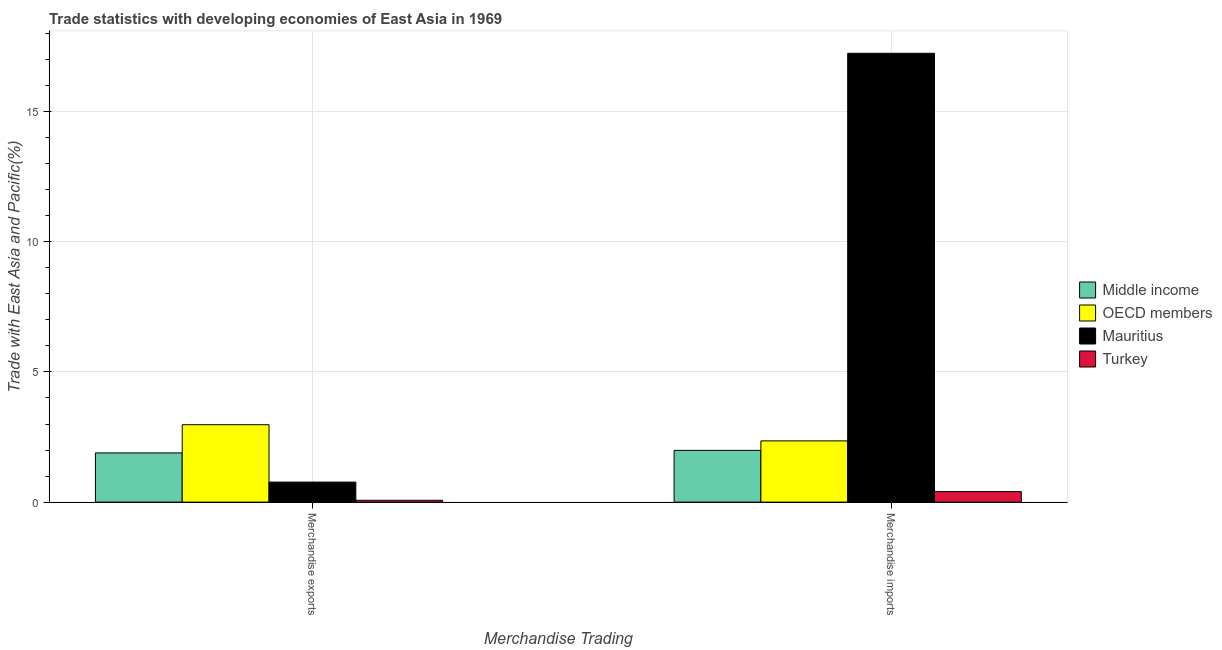Are the number of bars per tick equal to the number of legend labels?
Your answer should be compact. Yes. How many bars are there on the 1st tick from the right?
Make the answer very short. 4. What is the label of the 2nd group of bars from the left?
Provide a succinct answer. Merchandise imports. What is the merchandise exports in OECD members?
Your answer should be compact. 2.97. Across all countries, what is the maximum merchandise exports?
Keep it short and to the point. 2.97. Across all countries, what is the minimum merchandise imports?
Your response must be concise. 0.4. In which country was the merchandise imports maximum?
Provide a short and direct response. Mauritius. In which country was the merchandise exports minimum?
Offer a very short reply. Turkey. What is the total merchandise exports in the graph?
Your answer should be compact. 5.7. What is the difference between the merchandise imports in Middle income and that in OECD members?
Ensure brevity in your answer.  -0.37. What is the difference between the merchandise exports in Mauritius and the merchandise imports in Middle income?
Make the answer very short. -1.22. What is the average merchandise exports per country?
Provide a succinct answer. 1.43. What is the difference between the merchandise exports and merchandise imports in Middle income?
Make the answer very short. -0.1. In how many countries, is the merchandise imports greater than 3 %?
Your answer should be compact. 1. What is the ratio of the merchandise exports in Mauritius to that in OECD members?
Your response must be concise. 0.26. What does the 2nd bar from the left in Merchandise exports represents?
Your answer should be very brief. OECD members. How many bars are there?
Make the answer very short. 8. How many countries are there in the graph?
Give a very brief answer. 4. Does the graph contain any zero values?
Provide a succinct answer. No. Where does the legend appear in the graph?
Your answer should be very brief. Center right. How many legend labels are there?
Provide a short and direct response. 4. How are the legend labels stacked?
Ensure brevity in your answer.  Vertical. What is the title of the graph?
Your answer should be compact. Trade statistics with developing economies of East Asia in 1969. What is the label or title of the X-axis?
Provide a short and direct response. Merchandise Trading. What is the label or title of the Y-axis?
Your answer should be very brief. Trade with East Asia and Pacific(%). What is the Trade with East Asia and Pacific(%) in Middle income in Merchandise exports?
Offer a terse response. 1.89. What is the Trade with East Asia and Pacific(%) in OECD members in Merchandise exports?
Provide a short and direct response. 2.97. What is the Trade with East Asia and Pacific(%) in Mauritius in Merchandise exports?
Provide a succinct answer. 0.77. What is the Trade with East Asia and Pacific(%) in Turkey in Merchandise exports?
Offer a terse response. 0.07. What is the Trade with East Asia and Pacific(%) of Middle income in Merchandise imports?
Your response must be concise. 1.99. What is the Trade with East Asia and Pacific(%) in OECD members in Merchandise imports?
Provide a short and direct response. 2.35. What is the Trade with East Asia and Pacific(%) in Mauritius in Merchandise imports?
Provide a short and direct response. 17.24. What is the Trade with East Asia and Pacific(%) of Turkey in Merchandise imports?
Ensure brevity in your answer.  0.4. Across all Merchandise Trading, what is the maximum Trade with East Asia and Pacific(%) in Middle income?
Ensure brevity in your answer.  1.99. Across all Merchandise Trading, what is the maximum Trade with East Asia and Pacific(%) of OECD members?
Your answer should be compact. 2.97. Across all Merchandise Trading, what is the maximum Trade with East Asia and Pacific(%) in Mauritius?
Ensure brevity in your answer.  17.24. Across all Merchandise Trading, what is the maximum Trade with East Asia and Pacific(%) in Turkey?
Provide a succinct answer. 0.4. Across all Merchandise Trading, what is the minimum Trade with East Asia and Pacific(%) of Middle income?
Offer a terse response. 1.89. Across all Merchandise Trading, what is the minimum Trade with East Asia and Pacific(%) in OECD members?
Offer a terse response. 2.35. Across all Merchandise Trading, what is the minimum Trade with East Asia and Pacific(%) in Mauritius?
Your answer should be very brief. 0.77. Across all Merchandise Trading, what is the minimum Trade with East Asia and Pacific(%) in Turkey?
Make the answer very short. 0.07. What is the total Trade with East Asia and Pacific(%) of Middle income in the graph?
Offer a very short reply. 3.88. What is the total Trade with East Asia and Pacific(%) in OECD members in the graph?
Offer a terse response. 5.33. What is the total Trade with East Asia and Pacific(%) in Mauritius in the graph?
Give a very brief answer. 18.01. What is the total Trade with East Asia and Pacific(%) of Turkey in the graph?
Offer a terse response. 0.48. What is the difference between the Trade with East Asia and Pacific(%) in Middle income in Merchandise exports and that in Merchandise imports?
Your response must be concise. -0.1. What is the difference between the Trade with East Asia and Pacific(%) in OECD members in Merchandise exports and that in Merchandise imports?
Give a very brief answer. 0.62. What is the difference between the Trade with East Asia and Pacific(%) of Mauritius in Merchandise exports and that in Merchandise imports?
Provide a succinct answer. -16.47. What is the difference between the Trade with East Asia and Pacific(%) in Turkey in Merchandise exports and that in Merchandise imports?
Provide a short and direct response. -0.33. What is the difference between the Trade with East Asia and Pacific(%) in Middle income in Merchandise exports and the Trade with East Asia and Pacific(%) in OECD members in Merchandise imports?
Provide a short and direct response. -0.46. What is the difference between the Trade with East Asia and Pacific(%) in Middle income in Merchandise exports and the Trade with East Asia and Pacific(%) in Mauritius in Merchandise imports?
Make the answer very short. -15.35. What is the difference between the Trade with East Asia and Pacific(%) in Middle income in Merchandise exports and the Trade with East Asia and Pacific(%) in Turkey in Merchandise imports?
Provide a succinct answer. 1.49. What is the difference between the Trade with East Asia and Pacific(%) in OECD members in Merchandise exports and the Trade with East Asia and Pacific(%) in Mauritius in Merchandise imports?
Your answer should be very brief. -14.27. What is the difference between the Trade with East Asia and Pacific(%) in OECD members in Merchandise exports and the Trade with East Asia and Pacific(%) in Turkey in Merchandise imports?
Ensure brevity in your answer.  2.57. What is the difference between the Trade with East Asia and Pacific(%) in Mauritius in Merchandise exports and the Trade with East Asia and Pacific(%) in Turkey in Merchandise imports?
Keep it short and to the point. 0.36. What is the average Trade with East Asia and Pacific(%) of Middle income per Merchandise Trading?
Offer a terse response. 1.94. What is the average Trade with East Asia and Pacific(%) of OECD members per Merchandise Trading?
Your answer should be very brief. 2.66. What is the average Trade with East Asia and Pacific(%) of Mauritius per Merchandise Trading?
Keep it short and to the point. 9. What is the average Trade with East Asia and Pacific(%) in Turkey per Merchandise Trading?
Provide a succinct answer. 0.24. What is the difference between the Trade with East Asia and Pacific(%) of Middle income and Trade with East Asia and Pacific(%) of OECD members in Merchandise exports?
Ensure brevity in your answer.  -1.08. What is the difference between the Trade with East Asia and Pacific(%) in Middle income and Trade with East Asia and Pacific(%) in Mauritius in Merchandise exports?
Your answer should be very brief. 1.12. What is the difference between the Trade with East Asia and Pacific(%) of Middle income and Trade with East Asia and Pacific(%) of Turkey in Merchandise exports?
Make the answer very short. 1.82. What is the difference between the Trade with East Asia and Pacific(%) in OECD members and Trade with East Asia and Pacific(%) in Mauritius in Merchandise exports?
Ensure brevity in your answer.  2.2. What is the difference between the Trade with East Asia and Pacific(%) in OECD members and Trade with East Asia and Pacific(%) in Turkey in Merchandise exports?
Provide a short and direct response. 2.9. What is the difference between the Trade with East Asia and Pacific(%) in Mauritius and Trade with East Asia and Pacific(%) in Turkey in Merchandise exports?
Give a very brief answer. 0.7. What is the difference between the Trade with East Asia and Pacific(%) of Middle income and Trade with East Asia and Pacific(%) of OECD members in Merchandise imports?
Make the answer very short. -0.36. What is the difference between the Trade with East Asia and Pacific(%) in Middle income and Trade with East Asia and Pacific(%) in Mauritius in Merchandise imports?
Keep it short and to the point. -15.25. What is the difference between the Trade with East Asia and Pacific(%) of Middle income and Trade with East Asia and Pacific(%) of Turkey in Merchandise imports?
Offer a very short reply. 1.58. What is the difference between the Trade with East Asia and Pacific(%) in OECD members and Trade with East Asia and Pacific(%) in Mauritius in Merchandise imports?
Your answer should be very brief. -14.89. What is the difference between the Trade with East Asia and Pacific(%) in OECD members and Trade with East Asia and Pacific(%) in Turkey in Merchandise imports?
Keep it short and to the point. 1.95. What is the difference between the Trade with East Asia and Pacific(%) of Mauritius and Trade with East Asia and Pacific(%) of Turkey in Merchandise imports?
Your answer should be compact. 16.84. What is the ratio of the Trade with East Asia and Pacific(%) in Middle income in Merchandise exports to that in Merchandise imports?
Provide a short and direct response. 0.95. What is the ratio of the Trade with East Asia and Pacific(%) of OECD members in Merchandise exports to that in Merchandise imports?
Your answer should be compact. 1.26. What is the ratio of the Trade with East Asia and Pacific(%) of Mauritius in Merchandise exports to that in Merchandise imports?
Offer a very short reply. 0.04. What is the ratio of the Trade with East Asia and Pacific(%) in Turkey in Merchandise exports to that in Merchandise imports?
Your answer should be compact. 0.17. What is the difference between the highest and the second highest Trade with East Asia and Pacific(%) of Middle income?
Your response must be concise. 0.1. What is the difference between the highest and the second highest Trade with East Asia and Pacific(%) in OECD members?
Offer a very short reply. 0.62. What is the difference between the highest and the second highest Trade with East Asia and Pacific(%) of Mauritius?
Offer a very short reply. 16.47. What is the difference between the highest and the second highest Trade with East Asia and Pacific(%) in Turkey?
Your response must be concise. 0.33. What is the difference between the highest and the lowest Trade with East Asia and Pacific(%) in Middle income?
Your answer should be compact. 0.1. What is the difference between the highest and the lowest Trade with East Asia and Pacific(%) of OECD members?
Provide a short and direct response. 0.62. What is the difference between the highest and the lowest Trade with East Asia and Pacific(%) in Mauritius?
Offer a very short reply. 16.47. What is the difference between the highest and the lowest Trade with East Asia and Pacific(%) of Turkey?
Keep it short and to the point. 0.33. 